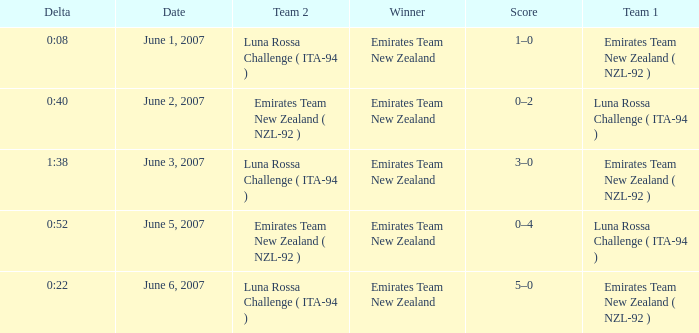Who is the Winner on June 2, 2007? Emirates Team New Zealand. 